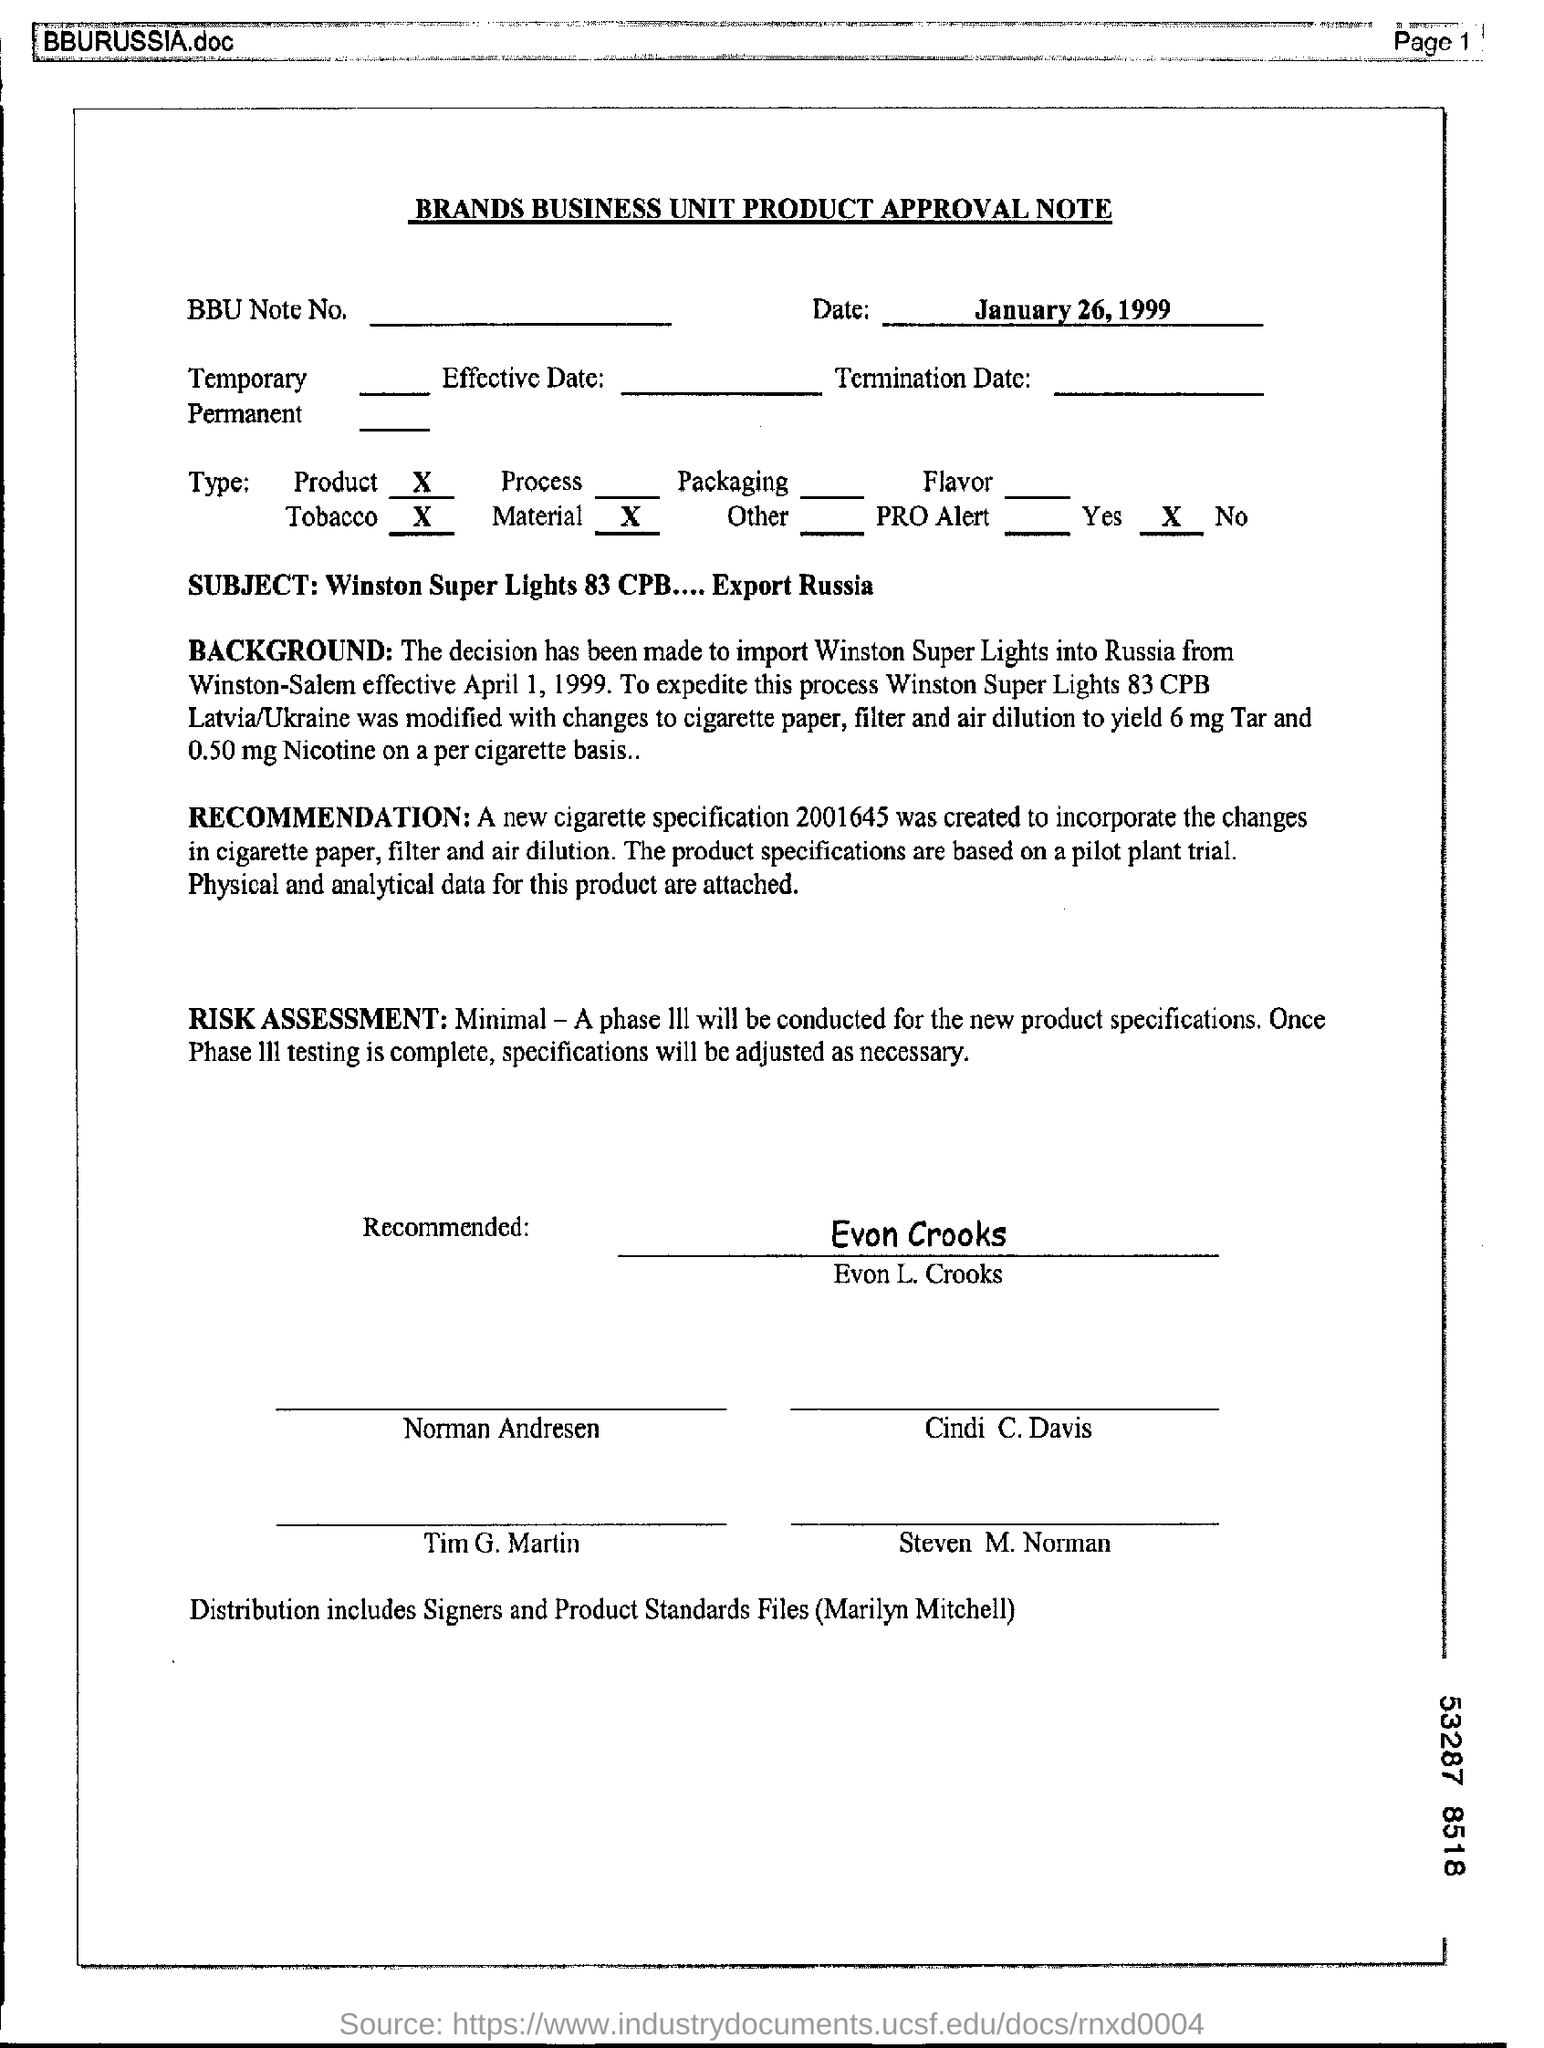From where are the cigarettes being imported ?
Make the answer very short. Winston-Salem. To which country is the Winston Super Lights being imported?
Give a very brief answer. Russia. In what all elements of the cigarette are changes made?
Your response must be concise. Cigarette paper, filter and air dilution. How much Nicotine is yielded per cigarette?
Provide a short and direct response. 0.50 mg. What is the new cigarette specification number ?
Provide a succinct answer. 2001645. Who has signed on the Approval Note?
Give a very brief answer. Evon L. Crooks. What is the Brand name of the cigarette?
Your answer should be very brief. Winston Super Lights. 